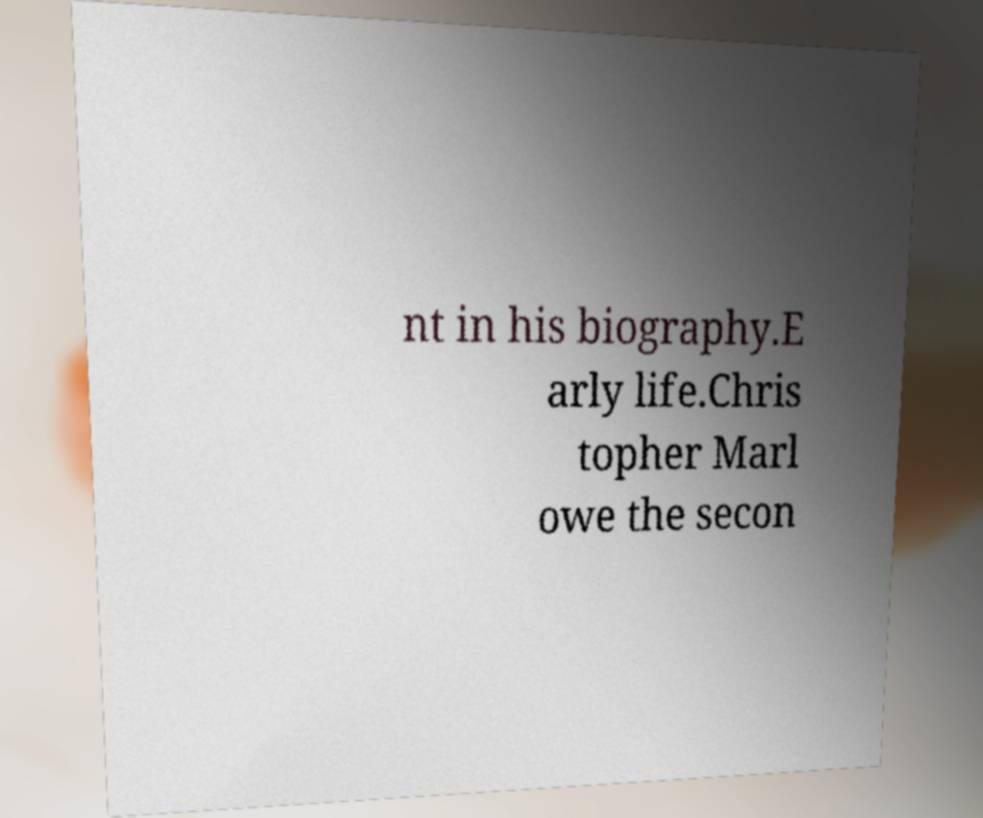Could you assist in decoding the text presented in this image and type it out clearly? nt in his biography.E arly life.Chris topher Marl owe the secon 